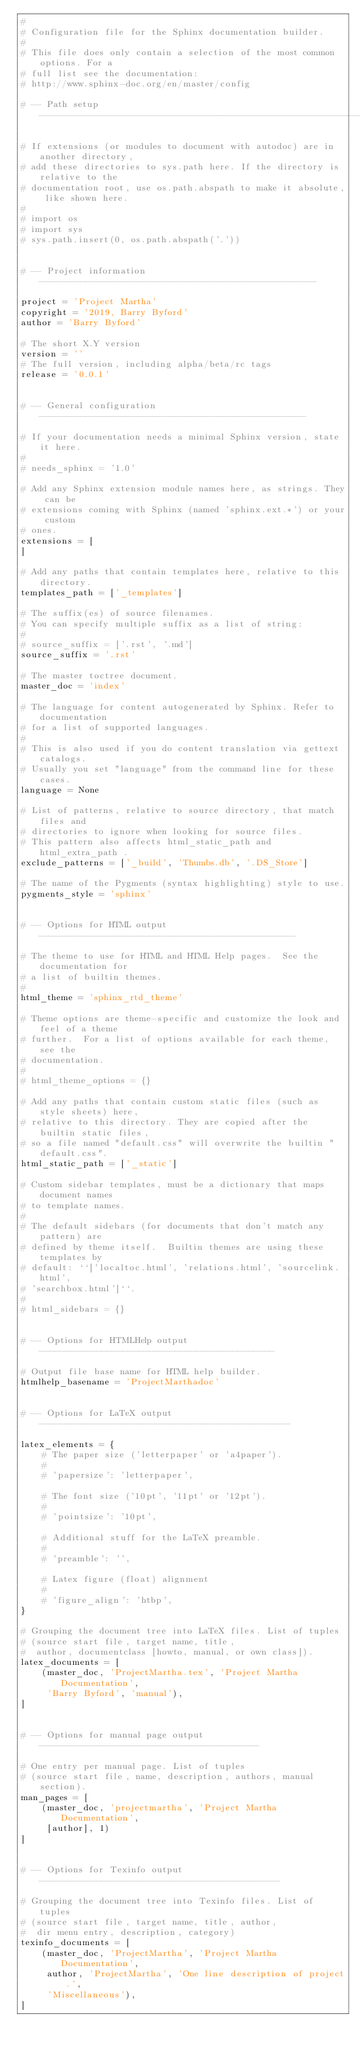Convert code to text. <code><loc_0><loc_0><loc_500><loc_500><_Python_>#
# Configuration file for the Sphinx documentation builder.
#
# This file does only contain a selection of the most common options. For a
# full list see the documentation:
# http://www.sphinx-doc.org/en/master/config

# -- Path setup --------------------------------------------------------------

# If extensions (or modules to document with autodoc) are in another directory,
# add these directories to sys.path here. If the directory is relative to the
# documentation root, use os.path.abspath to make it absolute, like shown here.
#
# import os
# import sys
# sys.path.insert(0, os.path.abspath('.'))


# -- Project information -----------------------------------------------------

project = 'Project Martha'
copyright = '2019, Barry Byford'
author = 'Barry Byford'

# The short X.Y version
version = ''
# The full version, including alpha/beta/rc tags
release = '0.0.1'


# -- General configuration ---------------------------------------------------

# If your documentation needs a minimal Sphinx version, state it here.
#
# needs_sphinx = '1.0'

# Add any Sphinx extension module names here, as strings. They can be
# extensions coming with Sphinx (named 'sphinx.ext.*') or your custom
# ones.
extensions = [
]

# Add any paths that contain templates here, relative to this directory.
templates_path = ['_templates']

# The suffix(es) of source filenames.
# You can specify multiple suffix as a list of string:
#
# source_suffix = ['.rst', '.md']
source_suffix = '.rst'

# The master toctree document.
master_doc = 'index'

# The language for content autogenerated by Sphinx. Refer to documentation
# for a list of supported languages.
#
# This is also used if you do content translation via gettext catalogs.
# Usually you set "language" from the command line for these cases.
language = None

# List of patterns, relative to source directory, that match files and
# directories to ignore when looking for source files.
# This pattern also affects html_static_path and html_extra_path .
exclude_patterns = ['_build', 'Thumbs.db', '.DS_Store']

# The name of the Pygments (syntax highlighting) style to use.
pygments_style = 'sphinx'


# -- Options for HTML output -------------------------------------------------

# The theme to use for HTML and HTML Help pages.  See the documentation for
# a list of builtin themes.
#
html_theme = 'sphinx_rtd_theme'

# Theme options are theme-specific and customize the look and feel of a theme
# further.  For a list of options available for each theme, see the
# documentation.
#
# html_theme_options = {}

# Add any paths that contain custom static files (such as style sheets) here,
# relative to this directory. They are copied after the builtin static files,
# so a file named "default.css" will overwrite the builtin "default.css".
html_static_path = ['_static']

# Custom sidebar templates, must be a dictionary that maps document names
# to template names.
#
# The default sidebars (for documents that don't match any pattern) are
# defined by theme itself.  Builtin themes are using these templates by
# default: ``['localtoc.html', 'relations.html', 'sourcelink.html',
# 'searchbox.html']``.
#
# html_sidebars = {}


# -- Options for HTMLHelp output ---------------------------------------------

# Output file base name for HTML help builder.
htmlhelp_basename = 'ProjectMarthadoc'


# -- Options for LaTeX output ------------------------------------------------

latex_elements = {
    # The paper size ('letterpaper' or 'a4paper').
    #
    # 'papersize': 'letterpaper',

    # The font size ('10pt', '11pt' or '12pt').
    #
    # 'pointsize': '10pt',

    # Additional stuff for the LaTeX preamble.
    #
    # 'preamble': '',

    # Latex figure (float) alignment
    #
    # 'figure_align': 'htbp',
}

# Grouping the document tree into LaTeX files. List of tuples
# (source start file, target name, title,
#  author, documentclass [howto, manual, or own class]).
latex_documents = [
    (master_doc, 'ProjectMartha.tex', 'Project Martha Documentation',
     'Barry Byford', 'manual'),
]


# -- Options for manual page output ------------------------------------------

# One entry per manual page. List of tuples
# (source start file, name, description, authors, manual section).
man_pages = [
    (master_doc, 'projectmartha', 'Project Martha Documentation',
     [author], 1)
]


# -- Options for Texinfo output ----------------------------------------------

# Grouping the document tree into Texinfo files. List of tuples
# (source start file, target name, title, author,
#  dir menu entry, description, category)
texinfo_documents = [
    (master_doc, 'ProjectMartha', 'Project Martha Documentation',
     author, 'ProjectMartha', 'One line description of project.',
     'Miscellaneous'),
]</code> 